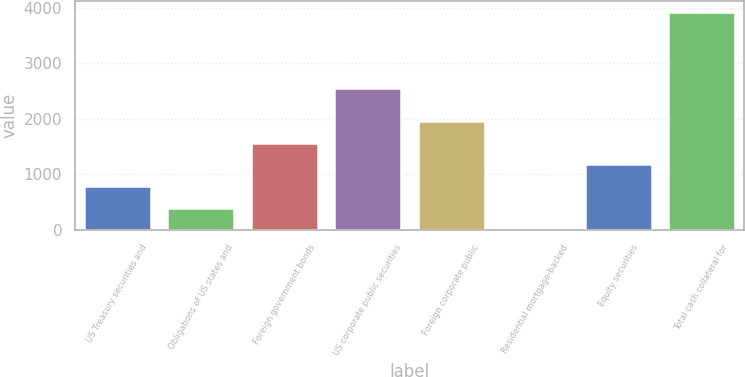Convert chart to OTSL. <chart><loc_0><loc_0><loc_500><loc_500><bar_chart><fcel>US Treasury securities and<fcel>Obligations of US states and<fcel>Foreign government bonds<fcel>US corporate public securities<fcel>Foreign corporate public<fcel>Residential mortgage-backed<fcel>Equity securities<fcel>Total cash collateral for<nl><fcel>787.53<fcel>394.85<fcel>1572.89<fcel>2563<fcel>1965.57<fcel>2.17<fcel>1180.21<fcel>3929<nl></chart> 